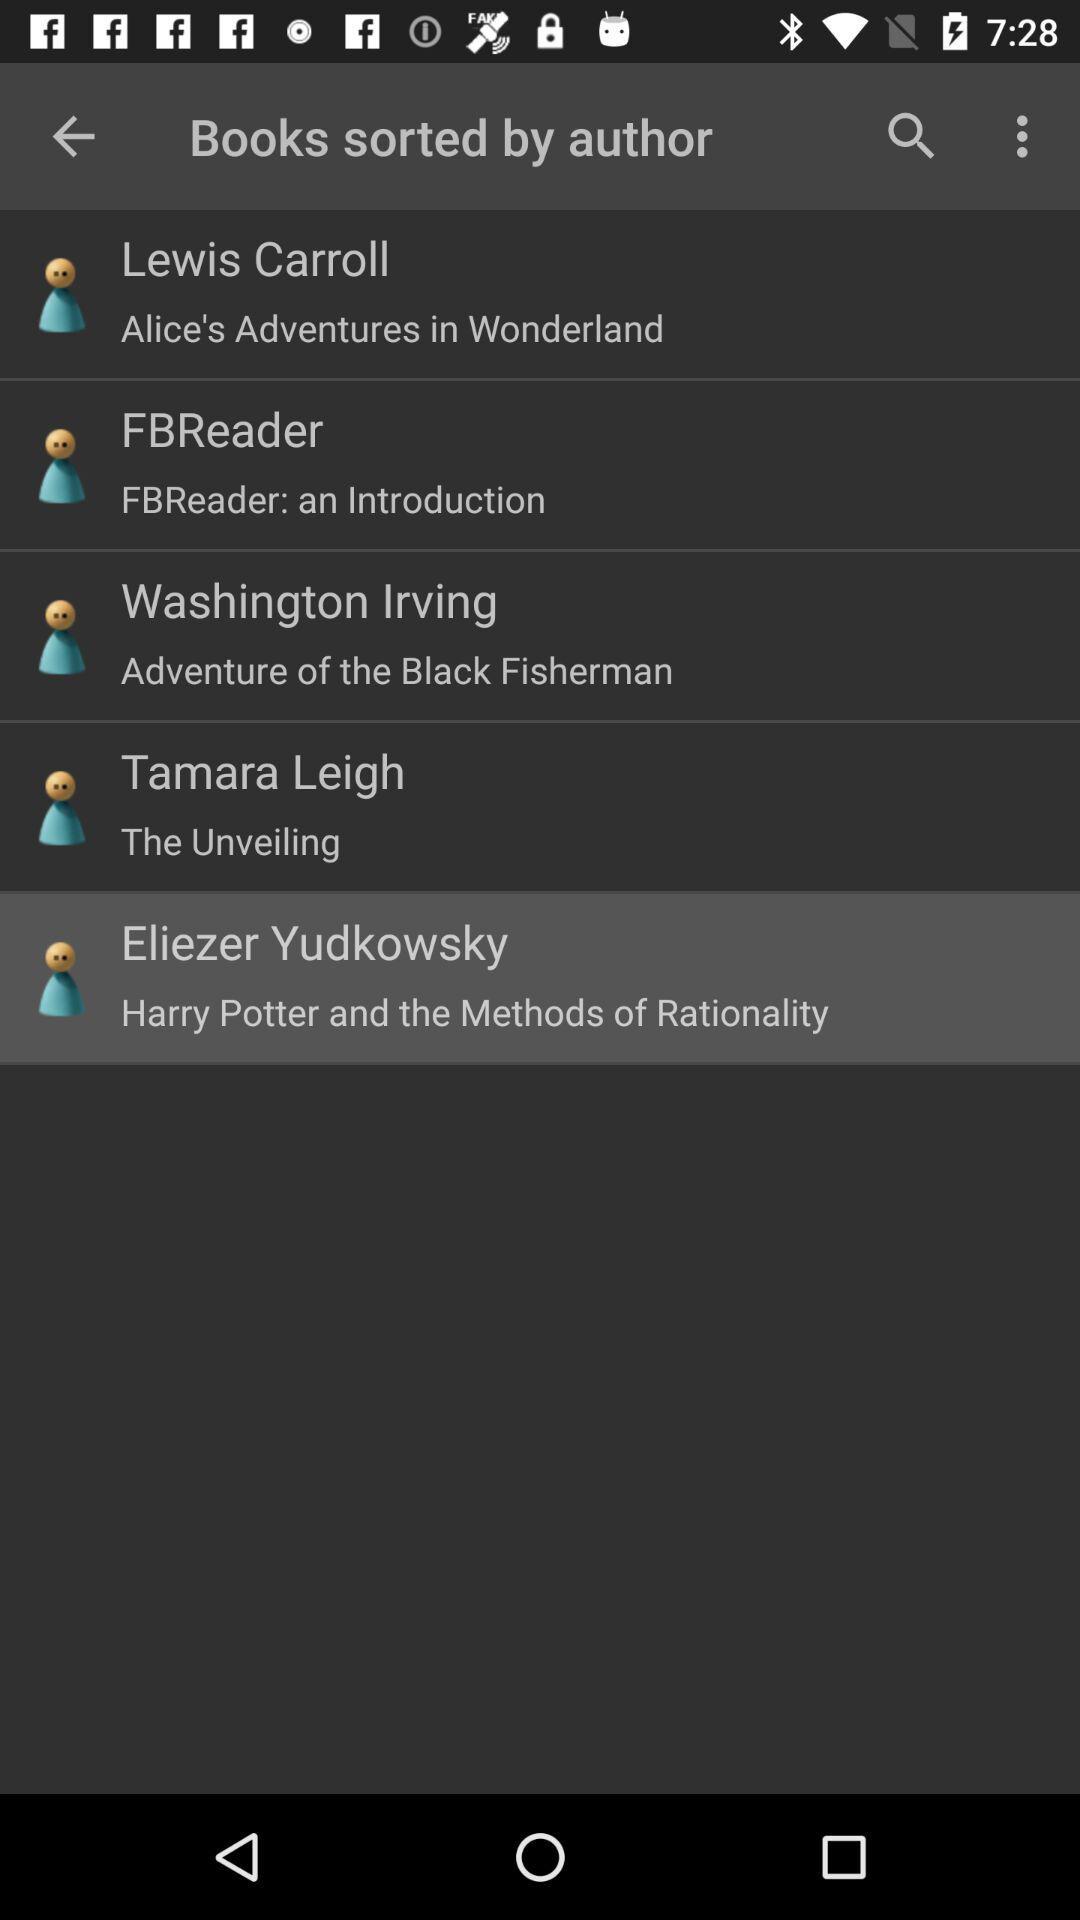Who is the author of "Adventure of the Black Fisherman"? The author is Washington Irving. 